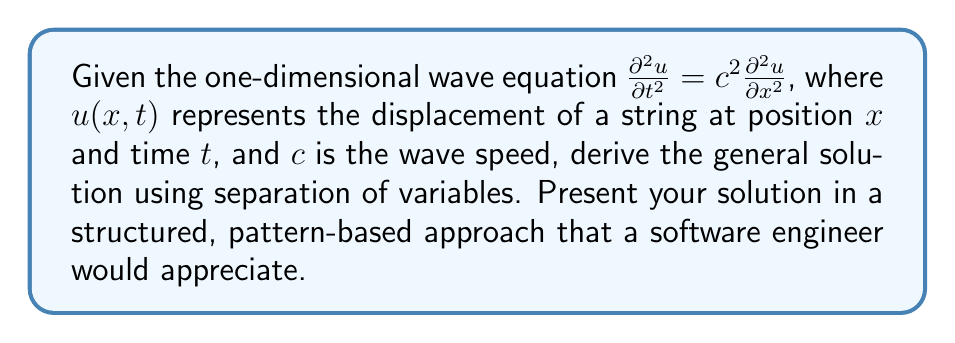Provide a solution to this math problem. Let's approach this problem systematically:

1) Assume a separable solution of the form:
   $$u(x,t) = X(x)T(t)$$

2) Substitute this into the wave equation:
   $$X(x)T''(t) = c^2X''(x)T(t)$$

3) Divide both sides by $X(x)T(t)$:
   $$\frac{T''(t)}{T(t)} = c^2\frac{X''(x)}{X(x)}$$

4) Since the left side depends only on $t$ and the right side only on $x$, both must equal a constant. Call this constant $-\lambda^2$:
   $$\frac{T''(t)}{T(t)} = -\lambda^2 = c^2\frac{X''(x)}{X(x)}$$

5) This gives us two ordinary differential equations:
   $$T''(t) + \lambda^2T(t) = 0$$
   $$X''(x) + \frac{\lambda^2}{c^2}X(x) = 0$$

6) The general solutions to these equations are:
   $$T(t) = A\cos(\lambda t) + B\sin(\lambda t)$$
   $$X(x) = C\cos(\frac{\lambda}{c}x) + D\sin(\frac{\lambda}{c}x)$$

7) Combining these, we get:
   $$u(x,t) = X(x)T(t) = (C\cos(\frac{\lambda}{c}x) + D\sin(\frac{\lambda}{c}x))(A\cos(\lambda t) + B\sin(\lambda t))$$

8) Expanding and regrouping:
   $$u(x,t) = AC\cos(\frac{\lambda}{c}x)\cos(\lambda t) + AD\sin(\frac{\lambda}{c}x)\cos(\lambda t) + BC\cos(\frac{\lambda}{c}x)\sin(\lambda t) + BD\sin(\frac{\lambda}{c}x)\sin(\lambda t)$$

9) Let $k = \frac{\lambda}{c}$. Then $\lambda = kc$, and we can rewrite:
   $$u(x,t) = E\cos(kx)\cos(kct) + F\sin(kx)\cos(kct) + G\cos(kx)\sin(kct) + H\sin(kx)\sin(kct)$$

   where $E, F, G, H$ are new constants.

10) This can be further simplified using trigonometric identities to:
    $$u(x,t) = f(x-ct) + g(x+ct)$$

    where $f$ and $g$ are arbitrary functions.
Answer: $u(x,t) = f(x-ct) + g(x+ct)$, where $f$ and $g$ are arbitrary functions. 